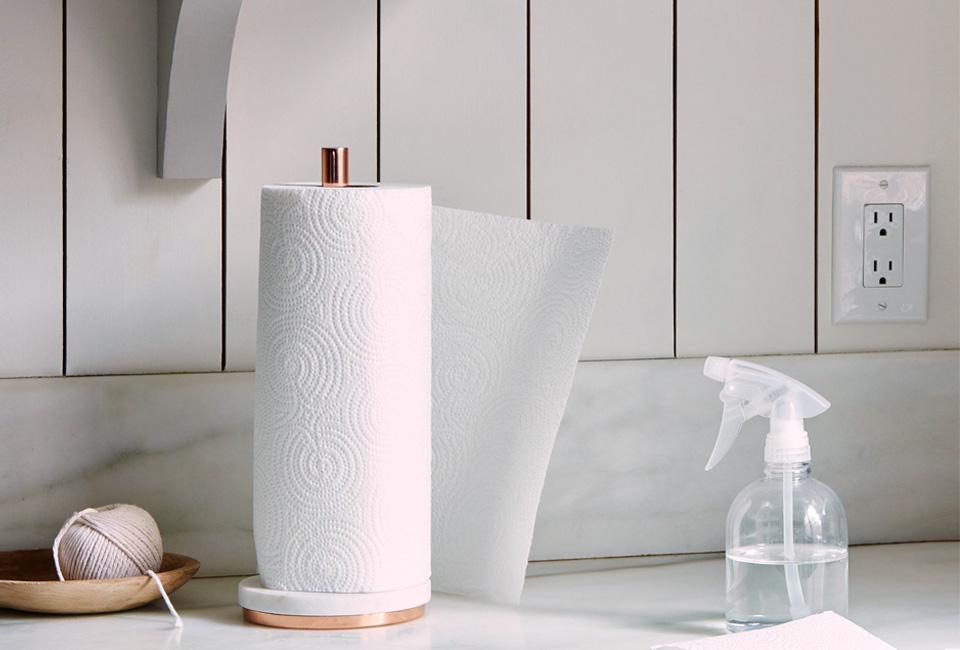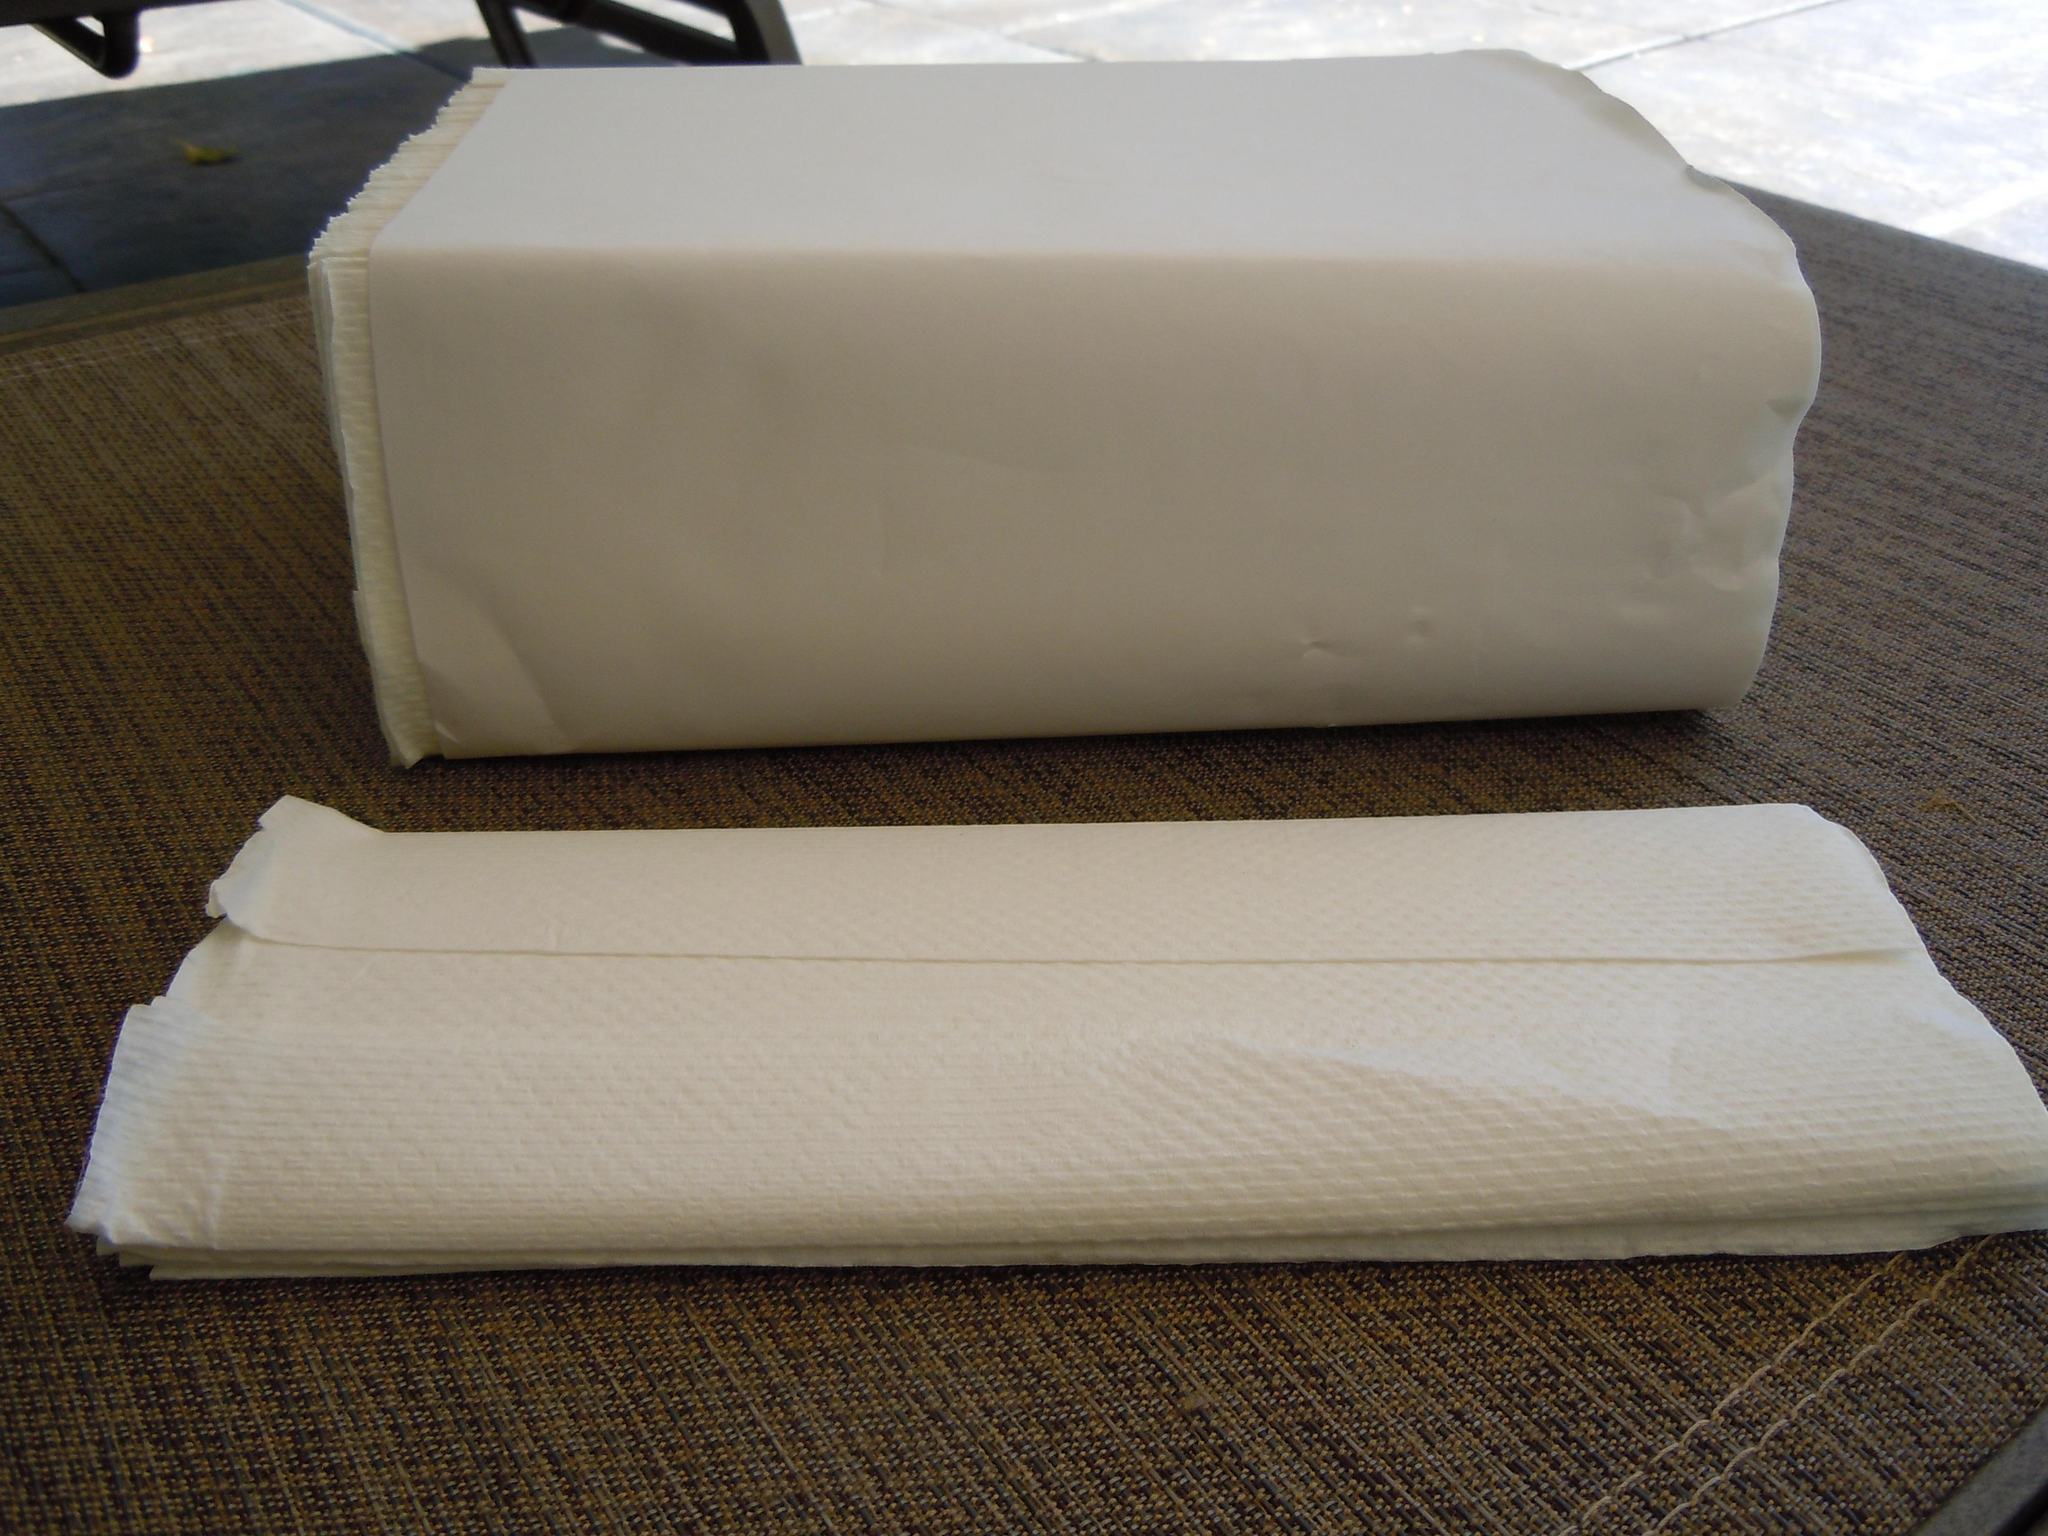The first image is the image on the left, the second image is the image on the right. Analyze the images presented: Is the assertion "At least one image shows a dispenser that is designed to be hung on the wall and fits rectangular napkins." valid? Answer yes or no. No. The first image is the image on the left, the second image is the image on the right. Given the left and right images, does the statement "An image shows one white paper towel roll on a stand with a post that sticks out at the top." hold true? Answer yes or no. Yes. 